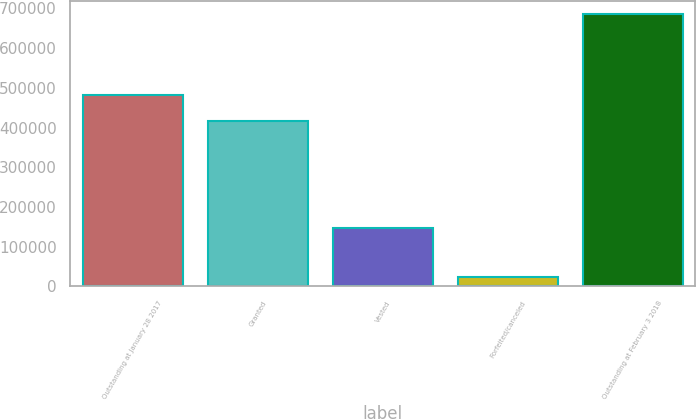<chart> <loc_0><loc_0><loc_500><loc_500><bar_chart><fcel>Outstanding at January 28 2017<fcel>Granted<fcel>Vested<fcel>Forfeited/canceled<fcel>Outstanding at February 3 2018<nl><fcel>482200<fcel>416000<fcel>146000<fcel>23000<fcel>685000<nl></chart> 